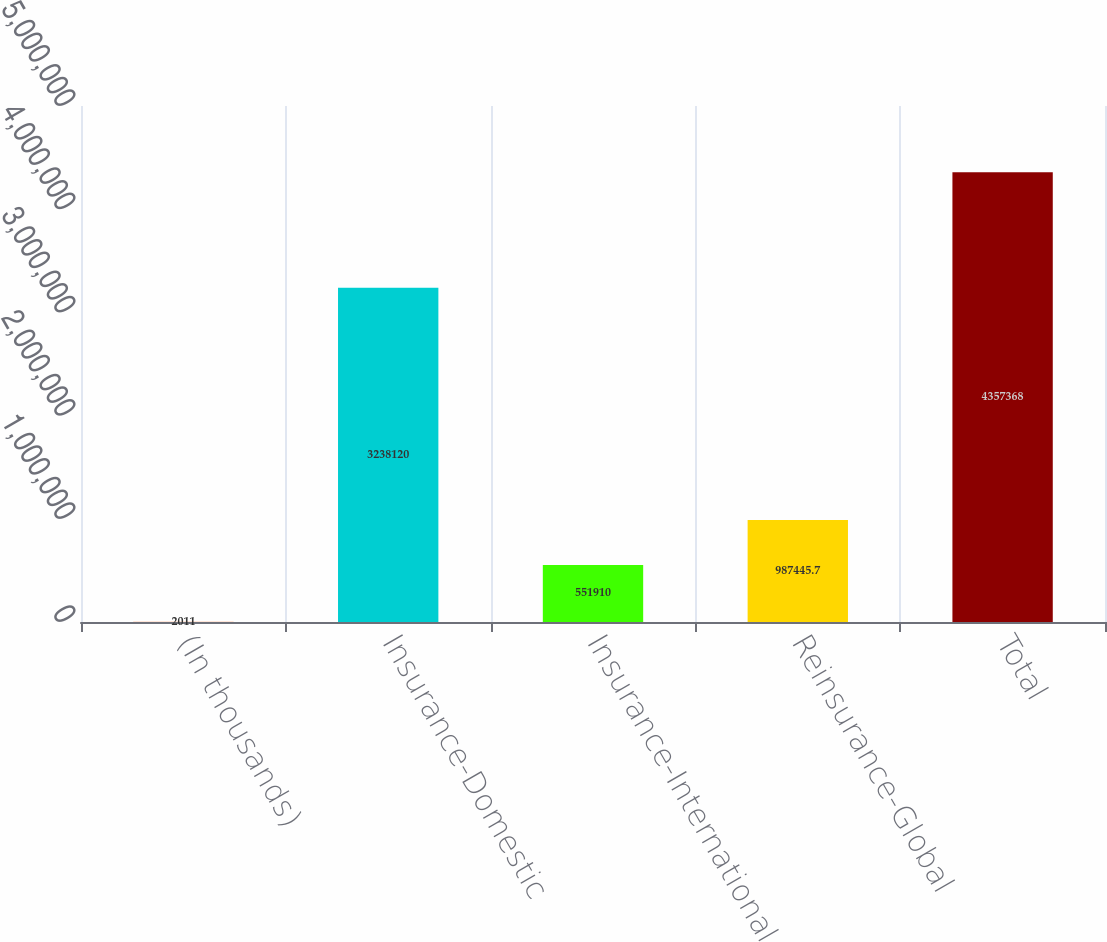<chart> <loc_0><loc_0><loc_500><loc_500><bar_chart><fcel>(In thousands)<fcel>Insurance-Domestic<fcel>Insurance-International<fcel>Reinsurance-Global<fcel>Total<nl><fcel>2011<fcel>3.23812e+06<fcel>551910<fcel>987446<fcel>4.35737e+06<nl></chart> 